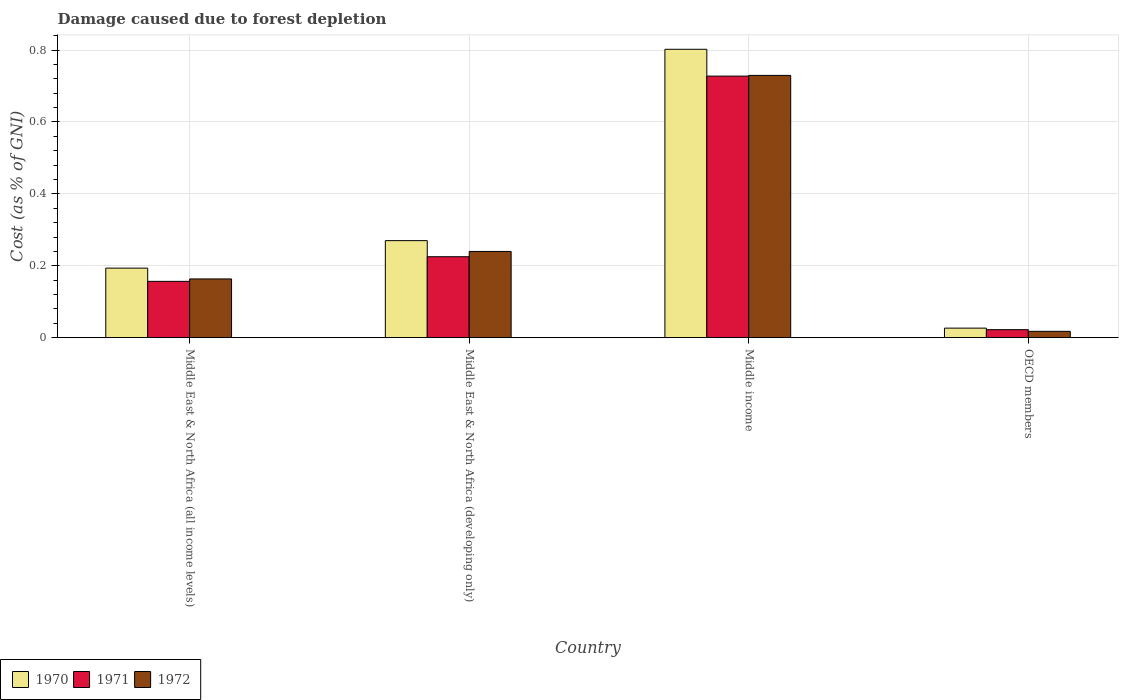In how many cases, is the number of bars for a given country not equal to the number of legend labels?
Make the answer very short. 0. What is the cost of damage caused due to forest depletion in 1970 in Middle East & North Africa (developing only)?
Offer a terse response. 0.27. Across all countries, what is the maximum cost of damage caused due to forest depletion in 1972?
Ensure brevity in your answer.  0.73. Across all countries, what is the minimum cost of damage caused due to forest depletion in 1970?
Your response must be concise. 0.03. In which country was the cost of damage caused due to forest depletion in 1971 maximum?
Offer a terse response. Middle income. What is the total cost of damage caused due to forest depletion in 1970 in the graph?
Make the answer very short. 1.29. What is the difference between the cost of damage caused due to forest depletion in 1971 in Middle East & North Africa (developing only) and that in Middle income?
Provide a succinct answer. -0.5. What is the difference between the cost of damage caused due to forest depletion in 1971 in Middle East & North Africa (developing only) and the cost of damage caused due to forest depletion in 1972 in OECD members?
Your answer should be compact. 0.21. What is the average cost of damage caused due to forest depletion in 1971 per country?
Provide a succinct answer. 0.28. What is the difference between the cost of damage caused due to forest depletion of/in 1971 and cost of damage caused due to forest depletion of/in 1970 in Middle income?
Your response must be concise. -0.07. In how many countries, is the cost of damage caused due to forest depletion in 1971 greater than 0.7600000000000001 %?
Make the answer very short. 0. What is the ratio of the cost of damage caused due to forest depletion in 1970 in Middle East & North Africa (all income levels) to that in OECD members?
Your response must be concise. 7.3. Is the cost of damage caused due to forest depletion in 1972 in Middle East & North Africa (all income levels) less than that in OECD members?
Offer a very short reply. No. Is the difference between the cost of damage caused due to forest depletion in 1971 in Middle income and OECD members greater than the difference between the cost of damage caused due to forest depletion in 1970 in Middle income and OECD members?
Keep it short and to the point. No. What is the difference between the highest and the second highest cost of damage caused due to forest depletion in 1972?
Your answer should be very brief. 0.49. What is the difference between the highest and the lowest cost of damage caused due to forest depletion in 1971?
Your answer should be compact. 0.71. In how many countries, is the cost of damage caused due to forest depletion in 1971 greater than the average cost of damage caused due to forest depletion in 1971 taken over all countries?
Offer a terse response. 1. Is the sum of the cost of damage caused due to forest depletion in 1971 in Middle East & North Africa (all income levels) and Middle income greater than the maximum cost of damage caused due to forest depletion in 1972 across all countries?
Your response must be concise. Yes. Are all the bars in the graph horizontal?
Give a very brief answer. No. How many countries are there in the graph?
Provide a succinct answer. 4. What is the difference between two consecutive major ticks on the Y-axis?
Your response must be concise. 0.2. Are the values on the major ticks of Y-axis written in scientific E-notation?
Offer a terse response. No. Does the graph contain any zero values?
Your answer should be very brief. No. Does the graph contain grids?
Keep it short and to the point. Yes. Where does the legend appear in the graph?
Your answer should be very brief. Bottom left. How many legend labels are there?
Offer a terse response. 3. What is the title of the graph?
Your response must be concise. Damage caused due to forest depletion. What is the label or title of the Y-axis?
Make the answer very short. Cost (as % of GNI). What is the Cost (as % of GNI) of 1970 in Middle East & North Africa (all income levels)?
Offer a terse response. 0.19. What is the Cost (as % of GNI) in 1971 in Middle East & North Africa (all income levels)?
Your answer should be very brief. 0.16. What is the Cost (as % of GNI) of 1972 in Middle East & North Africa (all income levels)?
Give a very brief answer. 0.16. What is the Cost (as % of GNI) of 1970 in Middle East & North Africa (developing only)?
Your response must be concise. 0.27. What is the Cost (as % of GNI) in 1971 in Middle East & North Africa (developing only)?
Your answer should be compact. 0.23. What is the Cost (as % of GNI) in 1972 in Middle East & North Africa (developing only)?
Make the answer very short. 0.24. What is the Cost (as % of GNI) in 1970 in Middle income?
Provide a short and direct response. 0.8. What is the Cost (as % of GNI) of 1971 in Middle income?
Offer a very short reply. 0.73. What is the Cost (as % of GNI) in 1972 in Middle income?
Your answer should be compact. 0.73. What is the Cost (as % of GNI) in 1970 in OECD members?
Your response must be concise. 0.03. What is the Cost (as % of GNI) of 1971 in OECD members?
Keep it short and to the point. 0.02. What is the Cost (as % of GNI) of 1972 in OECD members?
Make the answer very short. 0.02. Across all countries, what is the maximum Cost (as % of GNI) in 1970?
Your answer should be compact. 0.8. Across all countries, what is the maximum Cost (as % of GNI) in 1971?
Provide a short and direct response. 0.73. Across all countries, what is the maximum Cost (as % of GNI) in 1972?
Provide a succinct answer. 0.73. Across all countries, what is the minimum Cost (as % of GNI) of 1970?
Your answer should be compact. 0.03. Across all countries, what is the minimum Cost (as % of GNI) in 1971?
Ensure brevity in your answer.  0.02. Across all countries, what is the minimum Cost (as % of GNI) in 1972?
Your response must be concise. 0.02. What is the total Cost (as % of GNI) in 1970 in the graph?
Your answer should be compact. 1.29. What is the total Cost (as % of GNI) of 1971 in the graph?
Keep it short and to the point. 1.13. What is the total Cost (as % of GNI) of 1972 in the graph?
Your answer should be very brief. 1.15. What is the difference between the Cost (as % of GNI) of 1970 in Middle East & North Africa (all income levels) and that in Middle East & North Africa (developing only)?
Keep it short and to the point. -0.08. What is the difference between the Cost (as % of GNI) in 1971 in Middle East & North Africa (all income levels) and that in Middle East & North Africa (developing only)?
Provide a succinct answer. -0.07. What is the difference between the Cost (as % of GNI) of 1972 in Middle East & North Africa (all income levels) and that in Middle East & North Africa (developing only)?
Ensure brevity in your answer.  -0.08. What is the difference between the Cost (as % of GNI) of 1970 in Middle East & North Africa (all income levels) and that in Middle income?
Keep it short and to the point. -0.61. What is the difference between the Cost (as % of GNI) in 1971 in Middle East & North Africa (all income levels) and that in Middle income?
Your answer should be compact. -0.57. What is the difference between the Cost (as % of GNI) of 1972 in Middle East & North Africa (all income levels) and that in Middle income?
Make the answer very short. -0.57. What is the difference between the Cost (as % of GNI) in 1970 in Middle East & North Africa (all income levels) and that in OECD members?
Give a very brief answer. 0.17. What is the difference between the Cost (as % of GNI) of 1971 in Middle East & North Africa (all income levels) and that in OECD members?
Your answer should be compact. 0.13. What is the difference between the Cost (as % of GNI) in 1972 in Middle East & North Africa (all income levels) and that in OECD members?
Provide a short and direct response. 0.15. What is the difference between the Cost (as % of GNI) of 1970 in Middle East & North Africa (developing only) and that in Middle income?
Ensure brevity in your answer.  -0.53. What is the difference between the Cost (as % of GNI) of 1971 in Middle East & North Africa (developing only) and that in Middle income?
Offer a very short reply. -0.5. What is the difference between the Cost (as % of GNI) in 1972 in Middle East & North Africa (developing only) and that in Middle income?
Give a very brief answer. -0.49. What is the difference between the Cost (as % of GNI) of 1970 in Middle East & North Africa (developing only) and that in OECD members?
Your response must be concise. 0.24. What is the difference between the Cost (as % of GNI) of 1971 in Middle East & North Africa (developing only) and that in OECD members?
Keep it short and to the point. 0.2. What is the difference between the Cost (as % of GNI) of 1972 in Middle East & North Africa (developing only) and that in OECD members?
Provide a succinct answer. 0.22. What is the difference between the Cost (as % of GNI) in 1970 in Middle income and that in OECD members?
Offer a terse response. 0.78. What is the difference between the Cost (as % of GNI) of 1971 in Middle income and that in OECD members?
Your answer should be compact. 0.71. What is the difference between the Cost (as % of GNI) of 1972 in Middle income and that in OECD members?
Your response must be concise. 0.71. What is the difference between the Cost (as % of GNI) of 1970 in Middle East & North Africa (all income levels) and the Cost (as % of GNI) of 1971 in Middle East & North Africa (developing only)?
Offer a very short reply. -0.03. What is the difference between the Cost (as % of GNI) in 1970 in Middle East & North Africa (all income levels) and the Cost (as % of GNI) in 1972 in Middle East & North Africa (developing only)?
Offer a very short reply. -0.05. What is the difference between the Cost (as % of GNI) of 1971 in Middle East & North Africa (all income levels) and the Cost (as % of GNI) of 1972 in Middle East & North Africa (developing only)?
Your response must be concise. -0.08. What is the difference between the Cost (as % of GNI) in 1970 in Middle East & North Africa (all income levels) and the Cost (as % of GNI) in 1971 in Middle income?
Keep it short and to the point. -0.53. What is the difference between the Cost (as % of GNI) in 1970 in Middle East & North Africa (all income levels) and the Cost (as % of GNI) in 1972 in Middle income?
Make the answer very short. -0.54. What is the difference between the Cost (as % of GNI) of 1971 in Middle East & North Africa (all income levels) and the Cost (as % of GNI) of 1972 in Middle income?
Offer a very short reply. -0.57. What is the difference between the Cost (as % of GNI) of 1970 in Middle East & North Africa (all income levels) and the Cost (as % of GNI) of 1971 in OECD members?
Your answer should be compact. 0.17. What is the difference between the Cost (as % of GNI) of 1970 in Middle East & North Africa (all income levels) and the Cost (as % of GNI) of 1972 in OECD members?
Offer a terse response. 0.18. What is the difference between the Cost (as % of GNI) of 1971 in Middle East & North Africa (all income levels) and the Cost (as % of GNI) of 1972 in OECD members?
Offer a terse response. 0.14. What is the difference between the Cost (as % of GNI) of 1970 in Middle East & North Africa (developing only) and the Cost (as % of GNI) of 1971 in Middle income?
Offer a terse response. -0.46. What is the difference between the Cost (as % of GNI) of 1970 in Middle East & North Africa (developing only) and the Cost (as % of GNI) of 1972 in Middle income?
Provide a short and direct response. -0.46. What is the difference between the Cost (as % of GNI) of 1971 in Middle East & North Africa (developing only) and the Cost (as % of GNI) of 1972 in Middle income?
Offer a terse response. -0.5. What is the difference between the Cost (as % of GNI) in 1970 in Middle East & North Africa (developing only) and the Cost (as % of GNI) in 1971 in OECD members?
Keep it short and to the point. 0.25. What is the difference between the Cost (as % of GNI) in 1970 in Middle East & North Africa (developing only) and the Cost (as % of GNI) in 1972 in OECD members?
Provide a succinct answer. 0.25. What is the difference between the Cost (as % of GNI) of 1971 in Middle East & North Africa (developing only) and the Cost (as % of GNI) of 1972 in OECD members?
Give a very brief answer. 0.21. What is the difference between the Cost (as % of GNI) of 1970 in Middle income and the Cost (as % of GNI) of 1971 in OECD members?
Your answer should be very brief. 0.78. What is the difference between the Cost (as % of GNI) in 1970 in Middle income and the Cost (as % of GNI) in 1972 in OECD members?
Offer a terse response. 0.78. What is the difference between the Cost (as % of GNI) in 1971 in Middle income and the Cost (as % of GNI) in 1972 in OECD members?
Provide a short and direct response. 0.71. What is the average Cost (as % of GNI) in 1970 per country?
Ensure brevity in your answer.  0.32. What is the average Cost (as % of GNI) of 1971 per country?
Your answer should be compact. 0.28. What is the average Cost (as % of GNI) in 1972 per country?
Your answer should be very brief. 0.29. What is the difference between the Cost (as % of GNI) in 1970 and Cost (as % of GNI) in 1971 in Middle East & North Africa (all income levels)?
Your response must be concise. 0.04. What is the difference between the Cost (as % of GNI) in 1970 and Cost (as % of GNI) in 1972 in Middle East & North Africa (all income levels)?
Ensure brevity in your answer.  0.03. What is the difference between the Cost (as % of GNI) in 1971 and Cost (as % of GNI) in 1972 in Middle East & North Africa (all income levels)?
Your response must be concise. -0.01. What is the difference between the Cost (as % of GNI) in 1970 and Cost (as % of GNI) in 1971 in Middle East & North Africa (developing only)?
Your answer should be compact. 0.04. What is the difference between the Cost (as % of GNI) of 1970 and Cost (as % of GNI) of 1972 in Middle East & North Africa (developing only)?
Provide a short and direct response. 0.03. What is the difference between the Cost (as % of GNI) of 1971 and Cost (as % of GNI) of 1972 in Middle East & North Africa (developing only)?
Offer a very short reply. -0.01. What is the difference between the Cost (as % of GNI) in 1970 and Cost (as % of GNI) in 1971 in Middle income?
Keep it short and to the point. 0.07. What is the difference between the Cost (as % of GNI) in 1970 and Cost (as % of GNI) in 1972 in Middle income?
Give a very brief answer. 0.07. What is the difference between the Cost (as % of GNI) of 1971 and Cost (as % of GNI) of 1972 in Middle income?
Your answer should be very brief. -0. What is the difference between the Cost (as % of GNI) in 1970 and Cost (as % of GNI) in 1971 in OECD members?
Your answer should be compact. 0. What is the difference between the Cost (as % of GNI) of 1970 and Cost (as % of GNI) of 1972 in OECD members?
Offer a terse response. 0.01. What is the difference between the Cost (as % of GNI) of 1971 and Cost (as % of GNI) of 1972 in OECD members?
Your answer should be compact. 0. What is the ratio of the Cost (as % of GNI) of 1970 in Middle East & North Africa (all income levels) to that in Middle East & North Africa (developing only)?
Provide a short and direct response. 0.72. What is the ratio of the Cost (as % of GNI) of 1971 in Middle East & North Africa (all income levels) to that in Middle East & North Africa (developing only)?
Your response must be concise. 0.7. What is the ratio of the Cost (as % of GNI) of 1972 in Middle East & North Africa (all income levels) to that in Middle East & North Africa (developing only)?
Offer a terse response. 0.68. What is the ratio of the Cost (as % of GNI) in 1970 in Middle East & North Africa (all income levels) to that in Middle income?
Offer a very short reply. 0.24. What is the ratio of the Cost (as % of GNI) of 1971 in Middle East & North Africa (all income levels) to that in Middle income?
Offer a very short reply. 0.22. What is the ratio of the Cost (as % of GNI) in 1972 in Middle East & North Africa (all income levels) to that in Middle income?
Keep it short and to the point. 0.22. What is the ratio of the Cost (as % of GNI) in 1970 in Middle East & North Africa (all income levels) to that in OECD members?
Offer a terse response. 7.3. What is the ratio of the Cost (as % of GNI) of 1971 in Middle East & North Africa (all income levels) to that in OECD members?
Your answer should be very brief. 7.04. What is the ratio of the Cost (as % of GNI) in 1972 in Middle East & North Africa (all income levels) to that in OECD members?
Your response must be concise. 9.29. What is the ratio of the Cost (as % of GNI) of 1970 in Middle East & North Africa (developing only) to that in Middle income?
Offer a very short reply. 0.34. What is the ratio of the Cost (as % of GNI) of 1971 in Middle East & North Africa (developing only) to that in Middle income?
Offer a very short reply. 0.31. What is the ratio of the Cost (as % of GNI) of 1972 in Middle East & North Africa (developing only) to that in Middle income?
Provide a short and direct response. 0.33. What is the ratio of the Cost (as % of GNI) in 1970 in Middle East & North Africa (developing only) to that in OECD members?
Your response must be concise. 10.19. What is the ratio of the Cost (as % of GNI) of 1971 in Middle East & North Africa (developing only) to that in OECD members?
Your answer should be very brief. 10.12. What is the ratio of the Cost (as % of GNI) in 1972 in Middle East & North Africa (developing only) to that in OECD members?
Give a very brief answer. 13.63. What is the ratio of the Cost (as % of GNI) of 1970 in Middle income to that in OECD members?
Keep it short and to the point. 30.28. What is the ratio of the Cost (as % of GNI) in 1971 in Middle income to that in OECD members?
Ensure brevity in your answer.  32.71. What is the ratio of the Cost (as % of GNI) in 1972 in Middle income to that in OECD members?
Keep it short and to the point. 41.48. What is the difference between the highest and the second highest Cost (as % of GNI) of 1970?
Your response must be concise. 0.53. What is the difference between the highest and the second highest Cost (as % of GNI) of 1971?
Provide a succinct answer. 0.5. What is the difference between the highest and the second highest Cost (as % of GNI) in 1972?
Ensure brevity in your answer.  0.49. What is the difference between the highest and the lowest Cost (as % of GNI) in 1970?
Your answer should be compact. 0.78. What is the difference between the highest and the lowest Cost (as % of GNI) in 1971?
Ensure brevity in your answer.  0.71. What is the difference between the highest and the lowest Cost (as % of GNI) in 1972?
Your answer should be compact. 0.71. 